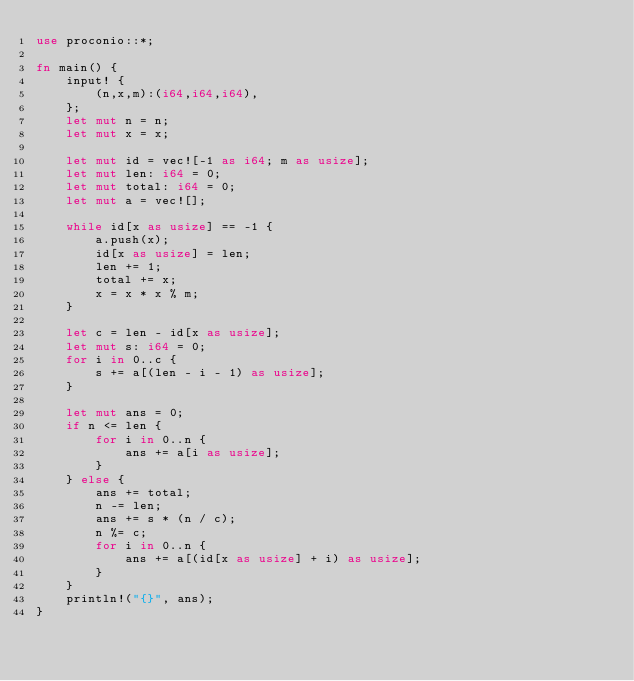<code> <loc_0><loc_0><loc_500><loc_500><_Rust_>use proconio::*;

fn main() {
    input! {
        (n,x,m):(i64,i64,i64),
    };
    let mut n = n;
    let mut x = x;

    let mut id = vec![-1 as i64; m as usize];
    let mut len: i64 = 0;
    let mut total: i64 = 0;
    let mut a = vec![];

    while id[x as usize] == -1 {
        a.push(x);
        id[x as usize] = len;
        len += 1;
        total += x;
        x = x * x % m;
    }

    let c = len - id[x as usize];
    let mut s: i64 = 0;
    for i in 0..c {
        s += a[(len - i - 1) as usize];
    }

    let mut ans = 0;
    if n <= len {
        for i in 0..n {
            ans += a[i as usize];
        }
    } else {
        ans += total;
        n -= len;
        ans += s * (n / c);
        n %= c;
        for i in 0..n {
            ans += a[(id[x as usize] + i) as usize];
        }
    }
    println!("{}", ans);
}
</code> 